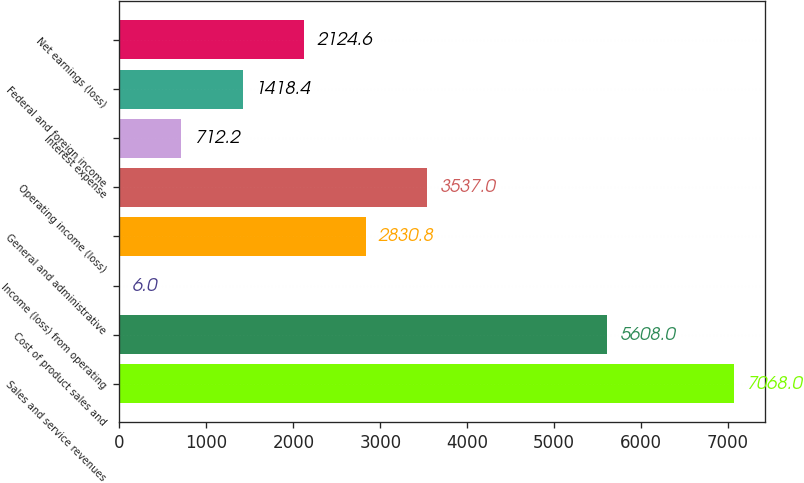<chart> <loc_0><loc_0><loc_500><loc_500><bar_chart><fcel>Sales and service revenues<fcel>Cost of product sales and<fcel>Income (loss) from operating<fcel>General and administrative<fcel>Operating income (loss)<fcel>Interest expense<fcel>Federal and foreign income<fcel>Net earnings (loss)<nl><fcel>7068<fcel>5608<fcel>6<fcel>2830.8<fcel>3537<fcel>712.2<fcel>1418.4<fcel>2124.6<nl></chart> 